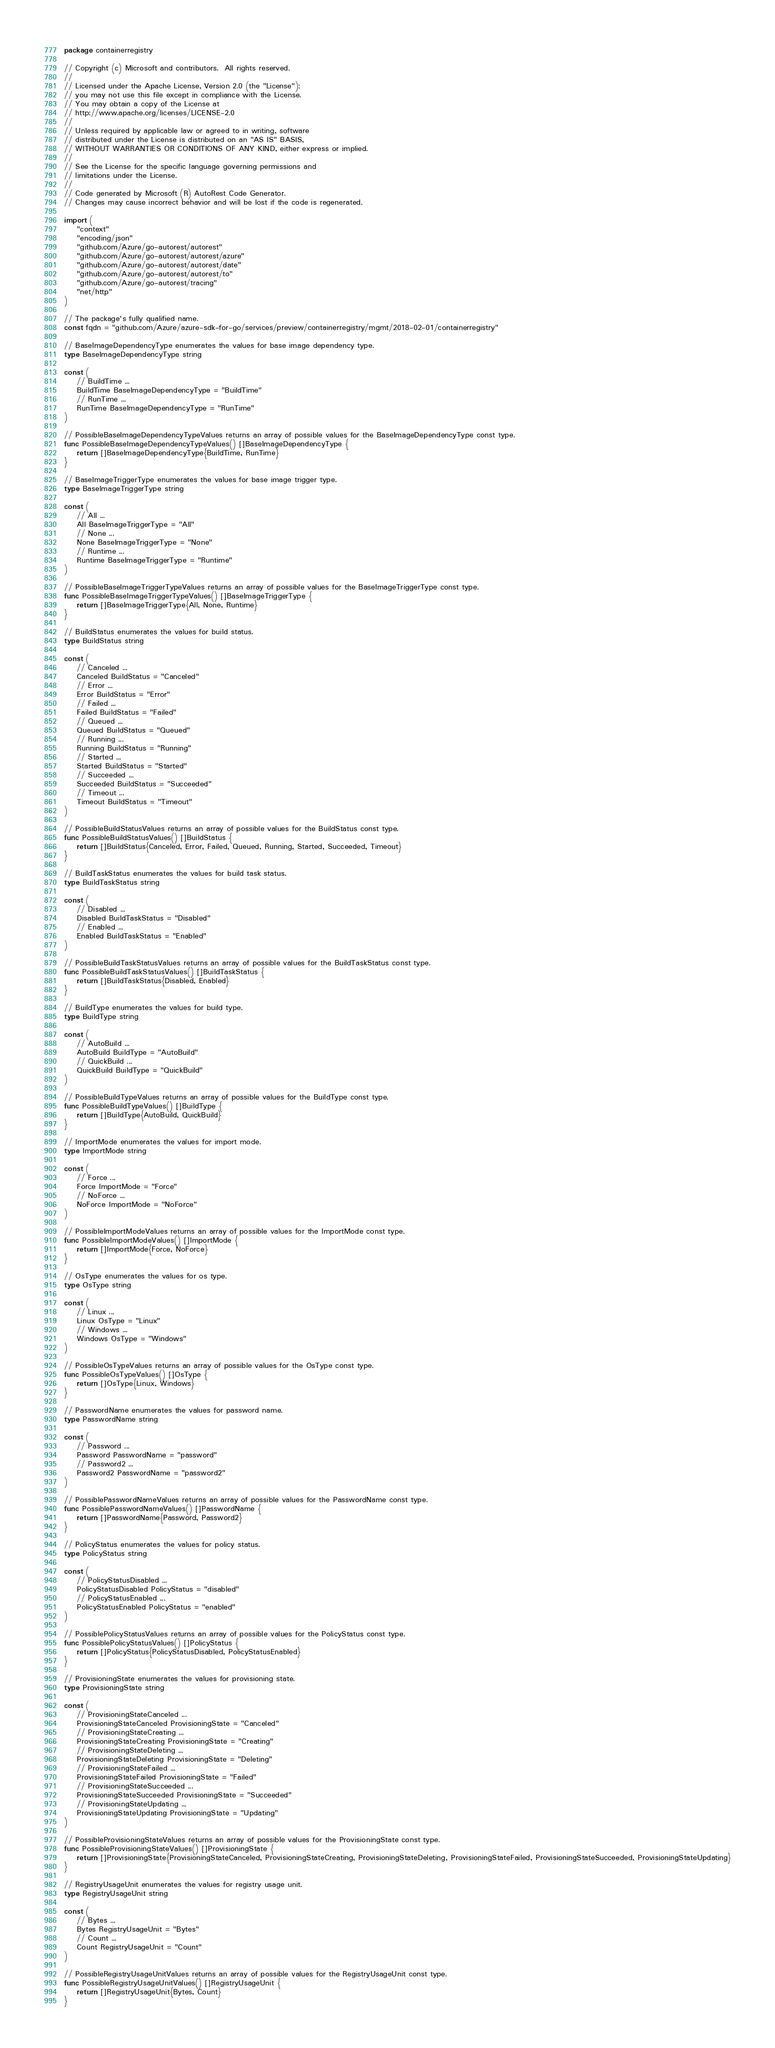Convert code to text. <code><loc_0><loc_0><loc_500><loc_500><_Go_>package containerregistry

// Copyright (c) Microsoft and contributors.  All rights reserved.
//
// Licensed under the Apache License, Version 2.0 (the "License");
// you may not use this file except in compliance with the License.
// You may obtain a copy of the License at
// http://www.apache.org/licenses/LICENSE-2.0
//
// Unless required by applicable law or agreed to in writing, software
// distributed under the License is distributed on an "AS IS" BASIS,
// WITHOUT WARRANTIES OR CONDITIONS OF ANY KIND, either express or implied.
//
// See the License for the specific language governing permissions and
// limitations under the License.
//
// Code generated by Microsoft (R) AutoRest Code Generator.
// Changes may cause incorrect behavior and will be lost if the code is regenerated.

import (
	"context"
	"encoding/json"
	"github.com/Azure/go-autorest/autorest"
	"github.com/Azure/go-autorest/autorest/azure"
	"github.com/Azure/go-autorest/autorest/date"
	"github.com/Azure/go-autorest/autorest/to"
	"github.com/Azure/go-autorest/tracing"
	"net/http"
)

// The package's fully qualified name.
const fqdn = "github.com/Azure/azure-sdk-for-go/services/preview/containerregistry/mgmt/2018-02-01/containerregistry"

// BaseImageDependencyType enumerates the values for base image dependency type.
type BaseImageDependencyType string

const (
	// BuildTime ...
	BuildTime BaseImageDependencyType = "BuildTime"
	// RunTime ...
	RunTime BaseImageDependencyType = "RunTime"
)

// PossibleBaseImageDependencyTypeValues returns an array of possible values for the BaseImageDependencyType const type.
func PossibleBaseImageDependencyTypeValues() []BaseImageDependencyType {
	return []BaseImageDependencyType{BuildTime, RunTime}
}

// BaseImageTriggerType enumerates the values for base image trigger type.
type BaseImageTriggerType string

const (
	// All ...
	All BaseImageTriggerType = "All"
	// None ...
	None BaseImageTriggerType = "None"
	// Runtime ...
	Runtime BaseImageTriggerType = "Runtime"
)

// PossibleBaseImageTriggerTypeValues returns an array of possible values for the BaseImageTriggerType const type.
func PossibleBaseImageTriggerTypeValues() []BaseImageTriggerType {
	return []BaseImageTriggerType{All, None, Runtime}
}

// BuildStatus enumerates the values for build status.
type BuildStatus string

const (
	// Canceled ...
	Canceled BuildStatus = "Canceled"
	// Error ...
	Error BuildStatus = "Error"
	// Failed ...
	Failed BuildStatus = "Failed"
	// Queued ...
	Queued BuildStatus = "Queued"
	// Running ...
	Running BuildStatus = "Running"
	// Started ...
	Started BuildStatus = "Started"
	// Succeeded ...
	Succeeded BuildStatus = "Succeeded"
	// Timeout ...
	Timeout BuildStatus = "Timeout"
)

// PossibleBuildStatusValues returns an array of possible values for the BuildStatus const type.
func PossibleBuildStatusValues() []BuildStatus {
	return []BuildStatus{Canceled, Error, Failed, Queued, Running, Started, Succeeded, Timeout}
}

// BuildTaskStatus enumerates the values for build task status.
type BuildTaskStatus string

const (
	// Disabled ...
	Disabled BuildTaskStatus = "Disabled"
	// Enabled ...
	Enabled BuildTaskStatus = "Enabled"
)

// PossibleBuildTaskStatusValues returns an array of possible values for the BuildTaskStatus const type.
func PossibleBuildTaskStatusValues() []BuildTaskStatus {
	return []BuildTaskStatus{Disabled, Enabled}
}

// BuildType enumerates the values for build type.
type BuildType string

const (
	// AutoBuild ...
	AutoBuild BuildType = "AutoBuild"
	// QuickBuild ...
	QuickBuild BuildType = "QuickBuild"
)

// PossibleBuildTypeValues returns an array of possible values for the BuildType const type.
func PossibleBuildTypeValues() []BuildType {
	return []BuildType{AutoBuild, QuickBuild}
}

// ImportMode enumerates the values for import mode.
type ImportMode string

const (
	// Force ...
	Force ImportMode = "Force"
	// NoForce ...
	NoForce ImportMode = "NoForce"
)

// PossibleImportModeValues returns an array of possible values for the ImportMode const type.
func PossibleImportModeValues() []ImportMode {
	return []ImportMode{Force, NoForce}
}

// OsType enumerates the values for os type.
type OsType string

const (
	// Linux ...
	Linux OsType = "Linux"
	// Windows ...
	Windows OsType = "Windows"
)

// PossibleOsTypeValues returns an array of possible values for the OsType const type.
func PossibleOsTypeValues() []OsType {
	return []OsType{Linux, Windows}
}

// PasswordName enumerates the values for password name.
type PasswordName string

const (
	// Password ...
	Password PasswordName = "password"
	// Password2 ...
	Password2 PasswordName = "password2"
)

// PossiblePasswordNameValues returns an array of possible values for the PasswordName const type.
func PossiblePasswordNameValues() []PasswordName {
	return []PasswordName{Password, Password2}
}

// PolicyStatus enumerates the values for policy status.
type PolicyStatus string

const (
	// PolicyStatusDisabled ...
	PolicyStatusDisabled PolicyStatus = "disabled"
	// PolicyStatusEnabled ...
	PolicyStatusEnabled PolicyStatus = "enabled"
)

// PossiblePolicyStatusValues returns an array of possible values for the PolicyStatus const type.
func PossiblePolicyStatusValues() []PolicyStatus {
	return []PolicyStatus{PolicyStatusDisabled, PolicyStatusEnabled}
}

// ProvisioningState enumerates the values for provisioning state.
type ProvisioningState string

const (
	// ProvisioningStateCanceled ...
	ProvisioningStateCanceled ProvisioningState = "Canceled"
	// ProvisioningStateCreating ...
	ProvisioningStateCreating ProvisioningState = "Creating"
	// ProvisioningStateDeleting ...
	ProvisioningStateDeleting ProvisioningState = "Deleting"
	// ProvisioningStateFailed ...
	ProvisioningStateFailed ProvisioningState = "Failed"
	// ProvisioningStateSucceeded ...
	ProvisioningStateSucceeded ProvisioningState = "Succeeded"
	// ProvisioningStateUpdating ...
	ProvisioningStateUpdating ProvisioningState = "Updating"
)

// PossibleProvisioningStateValues returns an array of possible values for the ProvisioningState const type.
func PossibleProvisioningStateValues() []ProvisioningState {
	return []ProvisioningState{ProvisioningStateCanceled, ProvisioningStateCreating, ProvisioningStateDeleting, ProvisioningStateFailed, ProvisioningStateSucceeded, ProvisioningStateUpdating}
}

// RegistryUsageUnit enumerates the values for registry usage unit.
type RegistryUsageUnit string

const (
	// Bytes ...
	Bytes RegistryUsageUnit = "Bytes"
	// Count ...
	Count RegistryUsageUnit = "Count"
)

// PossibleRegistryUsageUnitValues returns an array of possible values for the RegistryUsageUnit const type.
func PossibleRegistryUsageUnitValues() []RegistryUsageUnit {
	return []RegistryUsageUnit{Bytes, Count}
}
</code> 